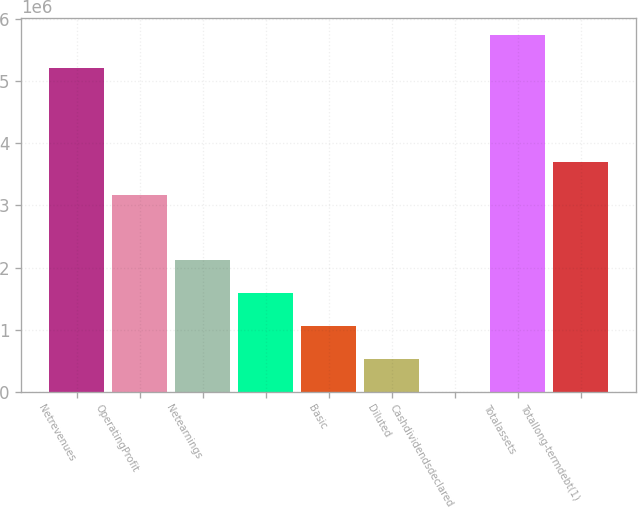<chart> <loc_0><loc_0><loc_500><loc_500><bar_chart><fcel>Netrevenues<fcel>OperatingProfit<fcel>Netearnings<fcel>Unnamed: 3<fcel>Basic<fcel>Diluted<fcel>Cashdividendsdeclared<fcel>Totalassets<fcel>Totallong-termdebt(1)<nl><fcel>5.20978e+06<fcel>3.17399e+06<fcel>2.11599e+06<fcel>1.587e+06<fcel>1.058e+06<fcel>529000<fcel>2.28<fcel>5.73878e+06<fcel>3.70299e+06<nl></chart> 